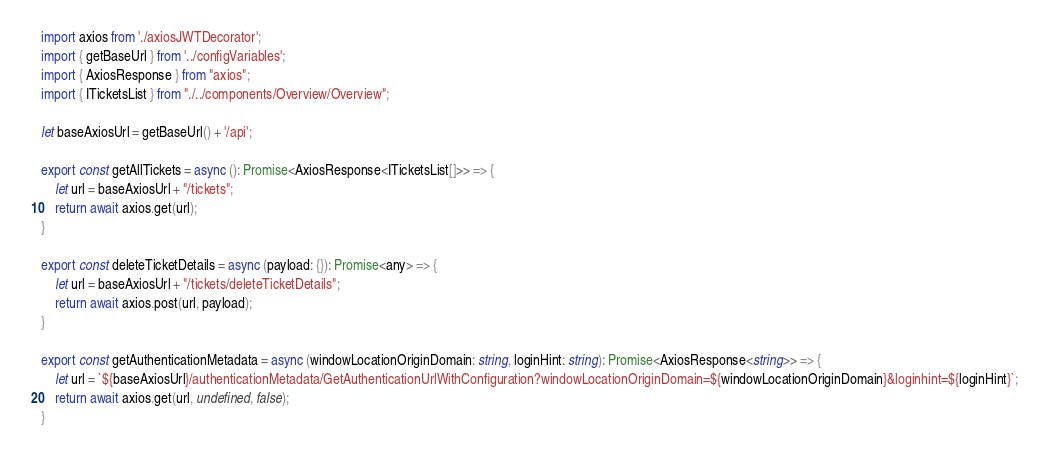Convert code to text. <code><loc_0><loc_0><loc_500><loc_500><_TypeScript_>import axios from './axiosJWTDecorator';
import { getBaseUrl } from '../configVariables';
import { AxiosResponse } from "axios";
import { ITicketsList } from "./../components/Overview/Overview";

let baseAxiosUrl = getBaseUrl() + '/api';

export const getAllTickets = async (): Promise<AxiosResponse<ITicketsList[]>> => {
    let url = baseAxiosUrl + "/tickets";
    return await axios.get(url);
}

export const deleteTicketDetails = async (payload: {}): Promise<any> => {
    let url = baseAxiosUrl + "/tickets/deleteTicketDetails";
    return await axios.post(url, payload);
}

export const getAuthenticationMetadata = async (windowLocationOriginDomain: string, loginHint: string): Promise<AxiosResponse<string>> => {
    let url = `${baseAxiosUrl}/authenticationMetadata/GetAuthenticationUrlWithConfiguration?windowLocationOriginDomain=${windowLocationOriginDomain}&loginhint=${loginHint}`;
    return await axios.get(url, undefined, false);
}
</code> 